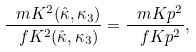Convert formula to latex. <formula><loc_0><loc_0><loc_500><loc_500>\frac { \ m K ^ { 2 } ( \hat { \kappa } , \kappa _ { 3 } ) } { \ f K ^ { 2 } ( \hat { \kappa } , \kappa _ { 3 } ) } = \frac { \ m K p ^ { 2 } } { \ f K p ^ { 2 } } ,</formula> 